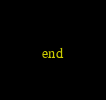Convert code to text. <code><loc_0><loc_0><loc_500><loc_500><_Ruby_>end
</code> 